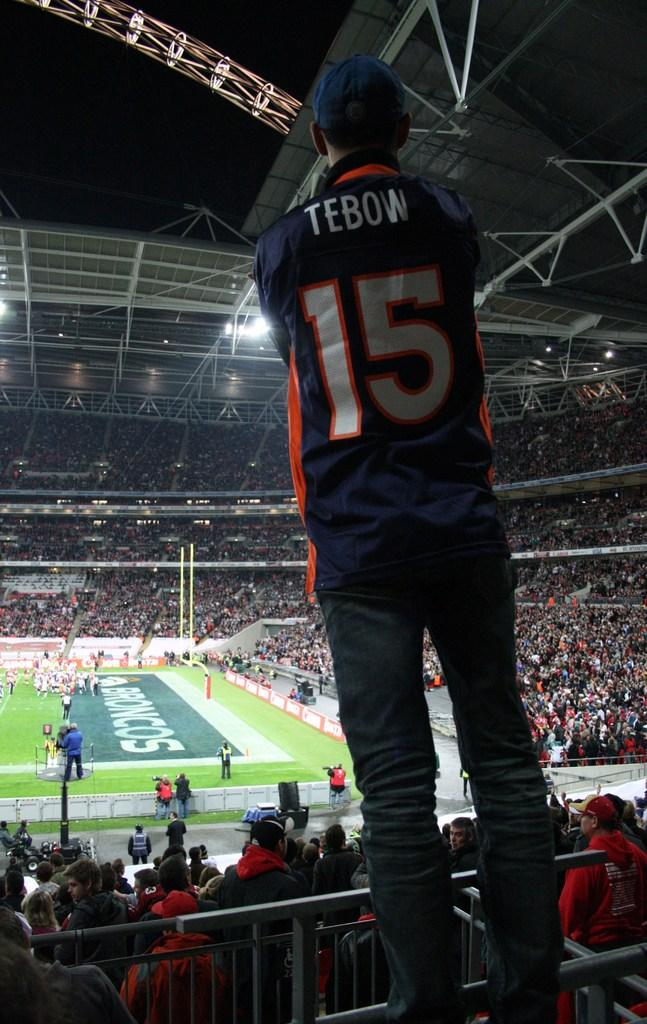What type of location is depicted in the image? The image is of a stadium. Can you describe any specific features of the stadium? There are iron rods and a lighting truss in the stadium. Are there any people present in the image? Yes, there is a person standing in the stadium, and there is also a group of people. What can be seen in the background of the image? The sky is visible in the background of the image. What might be used to illuminate the stadium during events? There are lights in the stadium for illumination. What type of government is in power in the image? There is no indication of a government in the image; it is a picture of a stadium with people and features. What type of steel is used to construct the lighting truss in the image? The image does not provide information about the type of steel used in the lighting truss. 